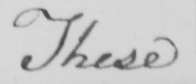Transcribe the text shown in this historical manuscript line. These 